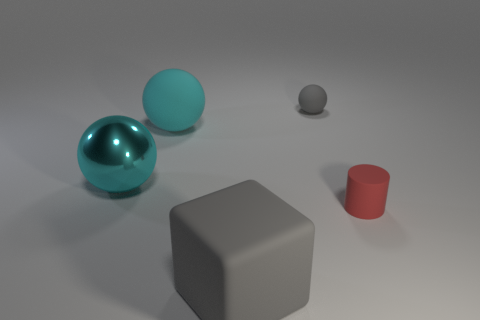What is the material of the ball that is on the right side of the big gray rubber thing?
Your answer should be compact. Rubber. There is a gray matte thing that is the same shape as the big cyan metal thing; what is its size?
Your answer should be compact. Small. Are there fewer big cyan things in front of the matte block than big yellow metal cubes?
Provide a succinct answer. No. Are any large purple shiny objects visible?
Your answer should be very brief. No. What is the color of the other tiny thing that is the same shape as the cyan metallic object?
Provide a short and direct response. Gray. There is a small rubber sphere on the right side of the block; is its color the same as the big rubber cube?
Make the answer very short. Yes. Is the size of the rubber block the same as the cyan matte object?
Provide a succinct answer. Yes. The big cyan thing that is the same material as the cube is what shape?
Provide a short and direct response. Sphere. How many other things are there of the same shape as the tiny red rubber thing?
Provide a succinct answer. 0. What is the shape of the gray object that is in front of the gray object that is behind the rubber object in front of the small cylinder?
Keep it short and to the point. Cube. 